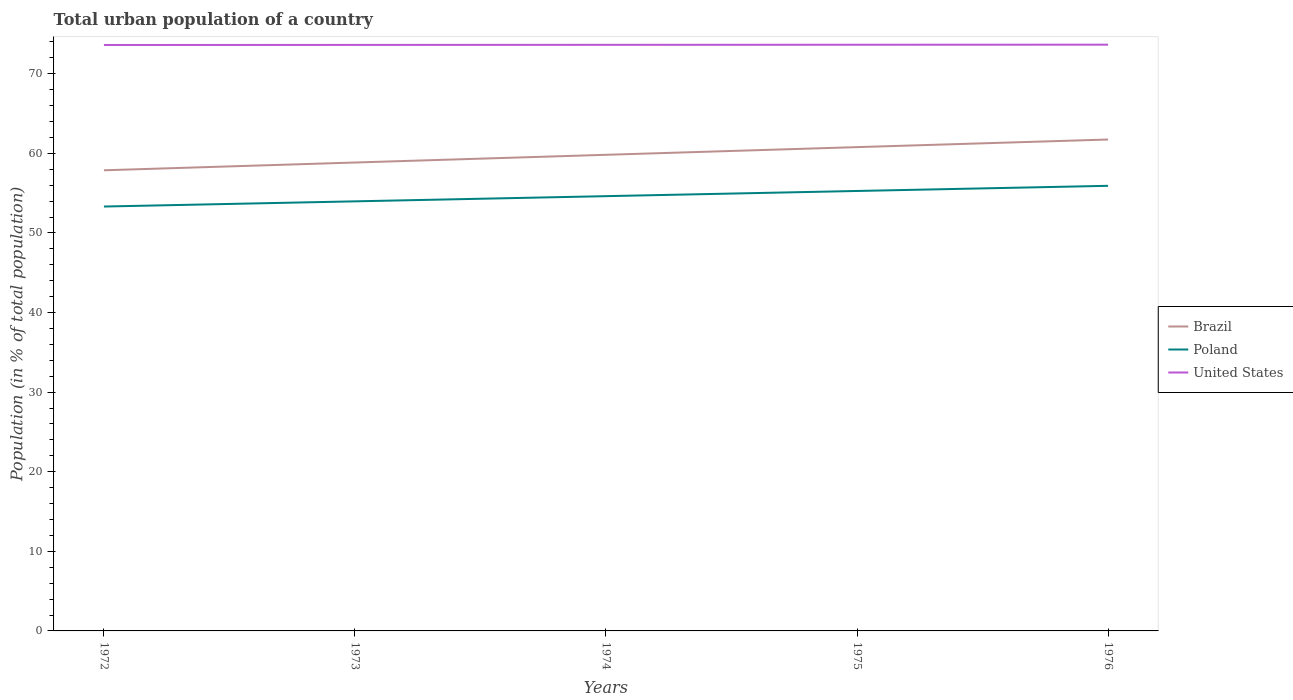How many different coloured lines are there?
Your response must be concise. 3. Across all years, what is the maximum urban population in Brazil?
Your answer should be compact. 57.88. What is the total urban population in Brazil in the graph?
Your answer should be compact. -0.96. What is the difference between the highest and the second highest urban population in United States?
Offer a terse response. 0.04. How many years are there in the graph?
Offer a very short reply. 5. What is the difference between two consecutive major ticks on the Y-axis?
Offer a very short reply. 10. Are the values on the major ticks of Y-axis written in scientific E-notation?
Ensure brevity in your answer.  No. Does the graph contain any zero values?
Your answer should be very brief. No. How many legend labels are there?
Your answer should be compact. 3. How are the legend labels stacked?
Provide a short and direct response. Vertical. What is the title of the graph?
Your answer should be compact. Total urban population of a country. Does "South Asia" appear as one of the legend labels in the graph?
Offer a very short reply. No. What is the label or title of the Y-axis?
Offer a terse response. Population (in % of total population). What is the Population (in % of total population) in Brazil in 1972?
Provide a short and direct response. 57.88. What is the Population (in % of total population) of Poland in 1972?
Ensure brevity in your answer.  53.32. What is the Population (in % of total population) of United States in 1972?
Provide a succinct answer. 73.62. What is the Population (in % of total population) of Brazil in 1973?
Your response must be concise. 58.85. What is the Population (in % of total population) in Poland in 1973?
Make the answer very short. 53.98. What is the Population (in % of total population) in United States in 1973?
Your answer should be compact. 73.63. What is the Population (in % of total population) of Brazil in 1974?
Keep it short and to the point. 59.83. What is the Population (in % of total population) of Poland in 1974?
Offer a very short reply. 54.63. What is the Population (in % of total population) in United States in 1974?
Make the answer very short. 73.64. What is the Population (in % of total population) of Brazil in 1975?
Your answer should be compact. 60.79. What is the Population (in % of total population) in Poland in 1975?
Keep it short and to the point. 55.28. What is the Population (in % of total population) of United States in 1975?
Provide a succinct answer. 73.65. What is the Population (in % of total population) in Brazil in 1976?
Keep it short and to the point. 61.74. What is the Population (in % of total population) in Poland in 1976?
Provide a short and direct response. 55.93. What is the Population (in % of total population) in United States in 1976?
Your answer should be compact. 73.66. Across all years, what is the maximum Population (in % of total population) in Brazil?
Your answer should be very brief. 61.74. Across all years, what is the maximum Population (in % of total population) in Poland?
Make the answer very short. 55.93. Across all years, what is the maximum Population (in % of total population) of United States?
Provide a short and direct response. 73.66. Across all years, what is the minimum Population (in % of total population) in Brazil?
Your response must be concise. 57.88. Across all years, what is the minimum Population (in % of total population) of Poland?
Give a very brief answer. 53.32. Across all years, what is the minimum Population (in % of total population) in United States?
Offer a very short reply. 73.62. What is the total Population (in % of total population) of Brazil in the graph?
Keep it short and to the point. 299.09. What is the total Population (in % of total population) of Poland in the graph?
Make the answer very short. 273.14. What is the total Population (in % of total population) in United States in the graph?
Offer a very short reply. 368.21. What is the difference between the Population (in % of total population) of Brazil in 1972 and that in 1973?
Give a very brief answer. -0.98. What is the difference between the Population (in % of total population) of Poland in 1972 and that in 1973?
Ensure brevity in your answer.  -0.65. What is the difference between the Population (in % of total population) in United States in 1972 and that in 1973?
Your response must be concise. -0.01. What is the difference between the Population (in % of total population) of Brazil in 1972 and that in 1974?
Offer a terse response. -1.95. What is the difference between the Population (in % of total population) in Poland in 1972 and that in 1974?
Make the answer very short. -1.3. What is the difference between the Population (in % of total population) in United States in 1972 and that in 1974?
Make the answer very short. -0.02. What is the difference between the Population (in % of total population) in Brazil in 1972 and that in 1975?
Your answer should be very brief. -2.91. What is the difference between the Population (in % of total population) in Poland in 1972 and that in 1975?
Give a very brief answer. -1.96. What is the difference between the Population (in % of total population) in United States in 1972 and that in 1975?
Offer a very short reply. -0.03. What is the difference between the Population (in % of total population) of Brazil in 1972 and that in 1976?
Your response must be concise. -3.87. What is the difference between the Population (in % of total population) in Poland in 1972 and that in 1976?
Provide a succinct answer. -2.6. What is the difference between the Population (in % of total population) of United States in 1972 and that in 1976?
Your answer should be compact. -0.04. What is the difference between the Population (in % of total population) in Brazil in 1973 and that in 1974?
Your response must be concise. -0.97. What is the difference between the Population (in % of total population) of Poland in 1973 and that in 1974?
Your answer should be compact. -0.65. What is the difference between the Population (in % of total population) in United States in 1973 and that in 1974?
Make the answer very short. -0.01. What is the difference between the Population (in % of total population) of Brazil in 1973 and that in 1975?
Give a very brief answer. -1.93. What is the difference between the Population (in % of total population) of Poland in 1973 and that in 1975?
Give a very brief answer. -1.3. What is the difference between the Population (in % of total population) of United States in 1973 and that in 1975?
Ensure brevity in your answer.  -0.02. What is the difference between the Population (in % of total population) in Brazil in 1973 and that in 1976?
Your answer should be very brief. -2.89. What is the difference between the Population (in % of total population) of Poland in 1973 and that in 1976?
Ensure brevity in your answer.  -1.95. What is the difference between the Population (in % of total population) in United States in 1973 and that in 1976?
Offer a very short reply. -0.03. What is the difference between the Population (in % of total population) in Brazil in 1974 and that in 1975?
Provide a succinct answer. -0.96. What is the difference between the Population (in % of total population) in Poland in 1974 and that in 1975?
Offer a terse response. -0.65. What is the difference between the Population (in % of total population) of United States in 1974 and that in 1975?
Offer a terse response. -0.01. What is the difference between the Population (in % of total population) in Brazil in 1974 and that in 1976?
Make the answer very short. -1.92. What is the difference between the Population (in % of total population) of Poland in 1974 and that in 1976?
Your answer should be compact. -1.3. What is the difference between the Population (in % of total population) of United States in 1974 and that in 1976?
Offer a terse response. -0.02. What is the difference between the Population (in % of total population) in Brazil in 1975 and that in 1976?
Offer a terse response. -0.96. What is the difference between the Population (in % of total population) in Poland in 1975 and that in 1976?
Offer a very short reply. -0.65. What is the difference between the Population (in % of total population) of United States in 1975 and that in 1976?
Your answer should be very brief. -0.01. What is the difference between the Population (in % of total population) in Brazil in 1972 and the Population (in % of total population) in Poland in 1973?
Your response must be concise. 3.9. What is the difference between the Population (in % of total population) of Brazil in 1972 and the Population (in % of total population) of United States in 1973?
Offer a very short reply. -15.75. What is the difference between the Population (in % of total population) of Poland in 1972 and the Population (in % of total population) of United States in 1973?
Your response must be concise. -20.31. What is the difference between the Population (in % of total population) of Brazil in 1972 and the Population (in % of total population) of United States in 1974?
Your answer should be very brief. -15.76. What is the difference between the Population (in % of total population) in Poland in 1972 and the Population (in % of total population) in United States in 1974?
Keep it short and to the point. -20.32. What is the difference between the Population (in % of total population) in Brazil in 1972 and the Population (in % of total population) in Poland in 1975?
Provide a short and direct response. 2.6. What is the difference between the Population (in % of total population) of Brazil in 1972 and the Population (in % of total population) of United States in 1975?
Provide a succinct answer. -15.77. What is the difference between the Population (in % of total population) in Poland in 1972 and the Population (in % of total population) in United States in 1975?
Provide a succinct answer. -20.33. What is the difference between the Population (in % of total population) in Brazil in 1972 and the Population (in % of total population) in Poland in 1976?
Offer a terse response. 1.95. What is the difference between the Population (in % of total population) of Brazil in 1972 and the Population (in % of total population) of United States in 1976?
Give a very brief answer. -15.78. What is the difference between the Population (in % of total population) of Poland in 1972 and the Population (in % of total population) of United States in 1976?
Your answer should be compact. -20.34. What is the difference between the Population (in % of total population) of Brazil in 1973 and the Population (in % of total population) of Poland in 1974?
Your answer should be very brief. 4.23. What is the difference between the Population (in % of total population) in Brazil in 1973 and the Population (in % of total population) in United States in 1974?
Provide a short and direct response. -14.79. What is the difference between the Population (in % of total population) in Poland in 1973 and the Population (in % of total population) in United States in 1974?
Give a very brief answer. -19.67. What is the difference between the Population (in % of total population) in Brazil in 1973 and the Population (in % of total population) in Poland in 1975?
Provide a short and direct response. 3.58. What is the difference between the Population (in % of total population) of Brazil in 1973 and the Population (in % of total population) of United States in 1975?
Your answer should be very brief. -14.8. What is the difference between the Population (in % of total population) in Poland in 1973 and the Population (in % of total population) in United States in 1975?
Give a very brief answer. -19.68. What is the difference between the Population (in % of total population) of Brazil in 1973 and the Population (in % of total population) of Poland in 1976?
Ensure brevity in your answer.  2.93. What is the difference between the Population (in % of total population) of Brazil in 1973 and the Population (in % of total population) of United States in 1976?
Offer a terse response. -14.81. What is the difference between the Population (in % of total population) of Poland in 1973 and the Population (in % of total population) of United States in 1976?
Your answer should be very brief. -19.69. What is the difference between the Population (in % of total population) in Brazil in 1974 and the Population (in % of total population) in Poland in 1975?
Ensure brevity in your answer.  4.55. What is the difference between the Population (in % of total population) in Brazil in 1974 and the Population (in % of total population) in United States in 1975?
Ensure brevity in your answer.  -13.83. What is the difference between the Population (in % of total population) in Poland in 1974 and the Population (in % of total population) in United States in 1975?
Your answer should be very brief. -19.02. What is the difference between the Population (in % of total population) of Brazil in 1974 and the Population (in % of total population) of Poland in 1976?
Your answer should be compact. 3.9. What is the difference between the Population (in % of total population) of Brazil in 1974 and the Population (in % of total population) of United States in 1976?
Your response must be concise. -13.84. What is the difference between the Population (in % of total population) in Poland in 1974 and the Population (in % of total population) in United States in 1976?
Offer a terse response. -19.03. What is the difference between the Population (in % of total population) of Brazil in 1975 and the Population (in % of total population) of Poland in 1976?
Provide a short and direct response. 4.86. What is the difference between the Population (in % of total population) in Brazil in 1975 and the Population (in % of total population) in United States in 1976?
Your answer should be very brief. -12.87. What is the difference between the Population (in % of total population) in Poland in 1975 and the Population (in % of total population) in United States in 1976?
Your response must be concise. -18.38. What is the average Population (in % of total population) in Brazil per year?
Provide a succinct answer. 59.82. What is the average Population (in % of total population) of Poland per year?
Make the answer very short. 54.63. What is the average Population (in % of total population) of United States per year?
Your answer should be very brief. 73.64. In the year 1972, what is the difference between the Population (in % of total population) in Brazil and Population (in % of total population) in Poland?
Give a very brief answer. 4.55. In the year 1972, what is the difference between the Population (in % of total population) in Brazil and Population (in % of total population) in United States?
Give a very brief answer. -15.74. In the year 1972, what is the difference between the Population (in % of total population) in Poland and Population (in % of total population) in United States?
Offer a very short reply. -20.3. In the year 1973, what is the difference between the Population (in % of total population) in Brazil and Population (in % of total population) in Poland?
Provide a short and direct response. 4.88. In the year 1973, what is the difference between the Population (in % of total population) in Brazil and Population (in % of total population) in United States?
Provide a succinct answer. -14.78. In the year 1973, what is the difference between the Population (in % of total population) in Poland and Population (in % of total population) in United States?
Ensure brevity in your answer.  -19.66. In the year 1974, what is the difference between the Population (in % of total population) in Brazil and Population (in % of total population) in Poland?
Offer a very short reply. 5.2. In the year 1974, what is the difference between the Population (in % of total population) in Brazil and Population (in % of total population) in United States?
Ensure brevity in your answer.  -13.82. In the year 1974, what is the difference between the Population (in % of total population) in Poland and Population (in % of total population) in United States?
Ensure brevity in your answer.  -19.01. In the year 1975, what is the difference between the Population (in % of total population) of Brazil and Population (in % of total population) of Poland?
Provide a short and direct response. 5.51. In the year 1975, what is the difference between the Population (in % of total population) in Brazil and Population (in % of total population) in United States?
Your response must be concise. -12.86. In the year 1975, what is the difference between the Population (in % of total population) of Poland and Population (in % of total population) of United States?
Keep it short and to the point. -18.37. In the year 1976, what is the difference between the Population (in % of total population) in Brazil and Population (in % of total population) in Poland?
Keep it short and to the point. 5.82. In the year 1976, what is the difference between the Population (in % of total population) in Brazil and Population (in % of total population) in United States?
Your answer should be compact. -11.92. In the year 1976, what is the difference between the Population (in % of total population) in Poland and Population (in % of total population) in United States?
Your answer should be very brief. -17.73. What is the ratio of the Population (in % of total population) of Brazil in 1972 to that in 1973?
Ensure brevity in your answer.  0.98. What is the ratio of the Population (in % of total population) in Poland in 1972 to that in 1973?
Offer a very short reply. 0.99. What is the ratio of the Population (in % of total population) in United States in 1972 to that in 1973?
Provide a short and direct response. 1. What is the ratio of the Population (in % of total population) of Brazil in 1972 to that in 1974?
Ensure brevity in your answer.  0.97. What is the ratio of the Population (in % of total population) in Poland in 1972 to that in 1974?
Keep it short and to the point. 0.98. What is the ratio of the Population (in % of total population) in United States in 1972 to that in 1974?
Your response must be concise. 1. What is the ratio of the Population (in % of total population) of Brazil in 1972 to that in 1975?
Offer a very short reply. 0.95. What is the ratio of the Population (in % of total population) in Poland in 1972 to that in 1975?
Provide a short and direct response. 0.96. What is the ratio of the Population (in % of total population) of United States in 1972 to that in 1975?
Offer a terse response. 1. What is the ratio of the Population (in % of total population) in Brazil in 1972 to that in 1976?
Your response must be concise. 0.94. What is the ratio of the Population (in % of total population) in Poland in 1972 to that in 1976?
Provide a succinct answer. 0.95. What is the ratio of the Population (in % of total population) of Brazil in 1973 to that in 1974?
Keep it short and to the point. 0.98. What is the ratio of the Population (in % of total population) of Poland in 1973 to that in 1974?
Offer a very short reply. 0.99. What is the ratio of the Population (in % of total population) in United States in 1973 to that in 1974?
Your answer should be compact. 1. What is the ratio of the Population (in % of total population) in Brazil in 1973 to that in 1975?
Provide a short and direct response. 0.97. What is the ratio of the Population (in % of total population) in Poland in 1973 to that in 1975?
Keep it short and to the point. 0.98. What is the ratio of the Population (in % of total population) of United States in 1973 to that in 1975?
Your answer should be compact. 1. What is the ratio of the Population (in % of total population) of Brazil in 1973 to that in 1976?
Offer a very short reply. 0.95. What is the ratio of the Population (in % of total population) of Poland in 1973 to that in 1976?
Your response must be concise. 0.97. What is the ratio of the Population (in % of total population) in United States in 1973 to that in 1976?
Provide a short and direct response. 1. What is the ratio of the Population (in % of total population) in Brazil in 1974 to that in 1975?
Your answer should be very brief. 0.98. What is the ratio of the Population (in % of total population) of Brazil in 1974 to that in 1976?
Make the answer very short. 0.97. What is the ratio of the Population (in % of total population) in Poland in 1974 to that in 1976?
Your answer should be very brief. 0.98. What is the ratio of the Population (in % of total population) of Brazil in 1975 to that in 1976?
Offer a very short reply. 0.98. What is the ratio of the Population (in % of total population) of Poland in 1975 to that in 1976?
Make the answer very short. 0.99. What is the ratio of the Population (in % of total population) of United States in 1975 to that in 1976?
Your response must be concise. 1. What is the difference between the highest and the second highest Population (in % of total population) of Brazil?
Offer a terse response. 0.96. What is the difference between the highest and the second highest Population (in % of total population) in Poland?
Provide a short and direct response. 0.65. What is the difference between the highest and the second highest Population (in % of total population) in United States?
Keep it short and to the point. 0.01. What is the difference between the highest and the lowest Population (in % of total population) in Brazil?
Your response must be concise. 3.87. What is the difference between the highest and the lowest Population (in % of total population) of Poland?
Make the answer very short. 2.6. What is the difference between the highest and the lowest Population (in % of total population) in United States?
Your answer should be very brief. 0.04. 